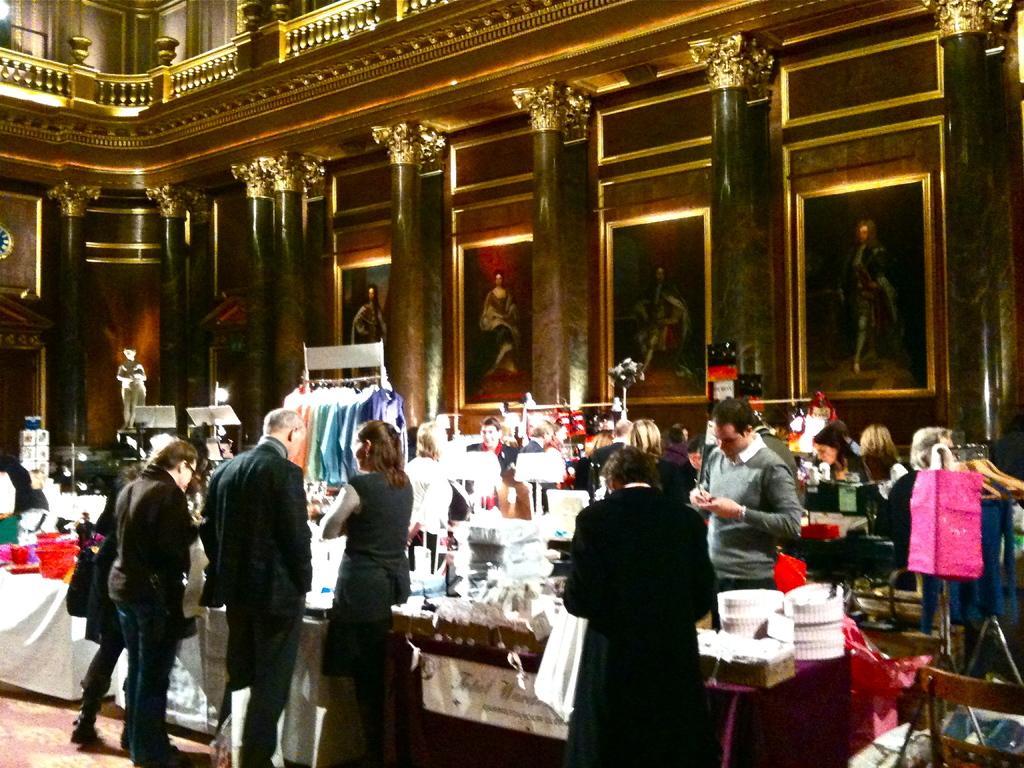How would you summarize this image in a sentence or two? In this image we can see people standing. There are stalls. In the background of the image there are photo frames, pillars. At the bottom of the image there is carpet. 